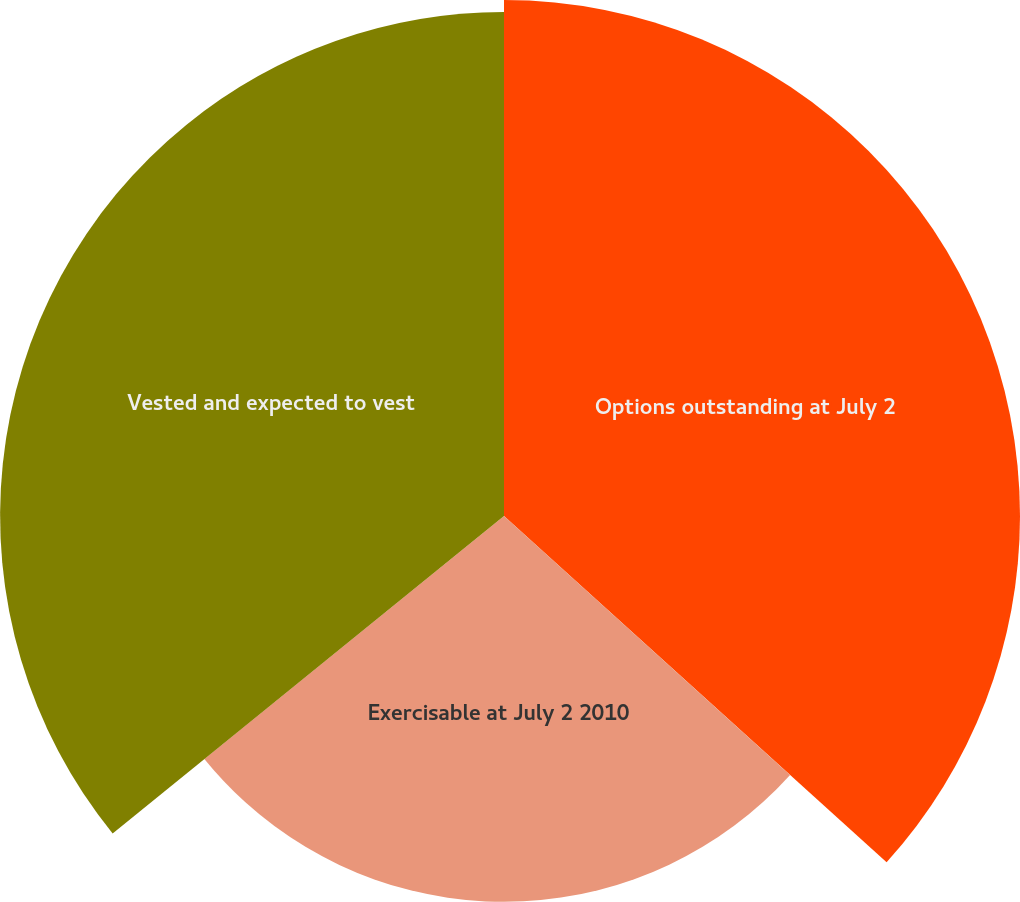Convert chart to OTSL. <chart><loc_0><loc_0><loc_500><loc_500><pie_chart><fcel>Options outstanding at July 2<fcel>Exercisable at July 2 2010<fcel>Vested and expected to vest<nl><fcel>36.71%<fcel>27.45%<fcel>35.85%<nl></chart> 